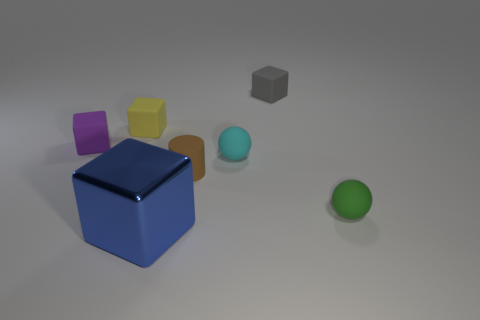Add 1 green metal cubes. How many objects exist? 8 Subtract all cylinders. How many objects are left? 6 Add 3 yellow shiny cylinders. How many yellow shiny cylinders exist? 3 Subtract 0 gray balls. How many objects are left? 7 Subtract all cyan matte balls. Subtract all yellow blocks. How many objects are left? 5 Add 5 small balls. How many small balls are left? 7 